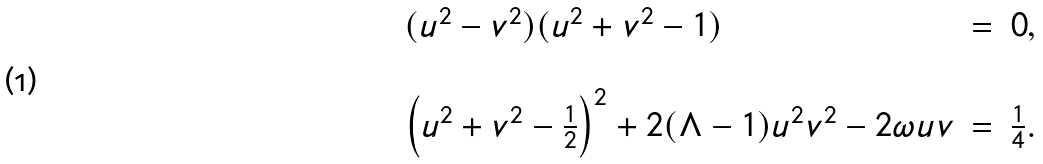<formula> <loc_0><loc_0><loc_500><loc_500>\begin{array} { l c r } ( u ^ { 2 } - v ^ { 2 } ) ( u ^ { 2 } + v ^ { 2 } - 1 ) & = & 0 , \\ & & \\ \left ( u ^ { 2 } + v ^ { 2 } - \frac { 1 } { 2 } \right ) ^ { 2 } + 2 ( \Lambda - 1 ) u ^ { 2 } v ^ { 2 } - 2 \omega u v & = & \frac { 1 } { 4 } . \end{array}</formula> 